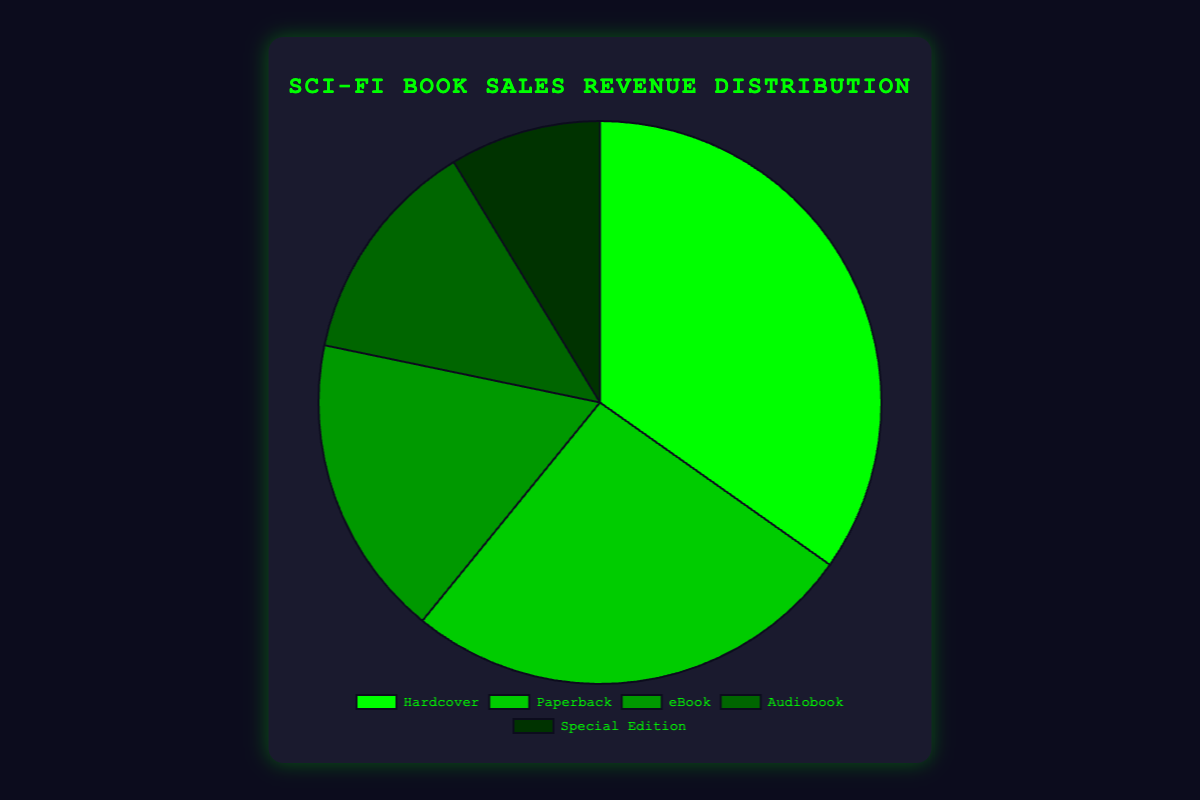Which book format generates the highest sales revenue? The pie chart indicates that 'Hardcover' has the largest segment, meaning it generates the highest sales revenue.
Answer: Hardcover What is the combined revenue of 'eBook' and 'Audiobook' formats? According to the pie chart, 'eBook' and 'Audiobook' revenues are $600,000 and $450,000 respectively. Adding them together gives: $600,000 + $450,000 = $1,050,000.
Answer: $1,050,000 Which format generates less revenue, 'Paperback' or 'Special Edition'? The pie chart shows that 'Special Edition' has a smaller segment compared to 'Paperback', indicating that it generates less revenue.
Answer: Special Edition What is the total revenue from 'Hardcover' and 'Paperback' formats combined? From the chart, the revenue for 'Hardcover' is $1,200,000 and for 'Paperback' is $900,000. The total combined revenue is $1,200,000 + $900,000 = $2,100,000.
Answer: $2,100,000 What percentage of the total sales revenue comes from 'Audiobook' format? First, sum up all the revenues: $1,200,000 (Hardcover) + $900,000 (Paperback) + $600,000 (eBook) + $450,000 (Audiobook) + $300,000 (Special Edition) = $3,450,000. Then, calculate the percentage for 'Audiobook': ($450,000 / $3,450,000) * 100 ≈ 13.04%
Answer: 13.04% Which format has half the revenue of 'Paperback'? According to the chart, 'Paperback' revenue is $900,000. Half of this is $900,000 / 2 = $450,000, which matches 'Audiobook'.
Answer: Audiobook What is the ratio of the total revenue generated by 'Hardcover' to that generated by 'eBook'? The revenue from 'Hardcover' is $1,200,000, and from 'eBook' is $600,000. The ratio is $1,200,000 / $600,000 = 2:1.
Answer: 2:1 If 'Special Edition' revenue were to increase by 50%, what would be its new revenue? The current revenue of 'Special Edition' is $300,000. An increase of 50% would be $300,000 * 0.5 = $150,000. Thus, the new revenue would be $300,000 + $150,000 = $450,000.
Answer: $450,000 By how much does the revenue of the format with the highest sales exceed the revenue of the format with the lowest sales? 'Hardcover' (highest) generates $1,200,000 and 'Special Edition' (lowest) generates $300,000. The difference is $1,200,000 - $300,000 = $900,000.
Answer: $900,000 What is the average revenue generated by all book formats? Sum up all revenues: $1,200,000
(Hardcover) + $900,000 (Paperback) + $600,000 (eBook) + $450,000 (Audiobook) + $300,000 (Special Edition) = $3,450,000. Divide by the number of formats: $3,450,000 / 5 = $690,000.
Answer: $690,000 